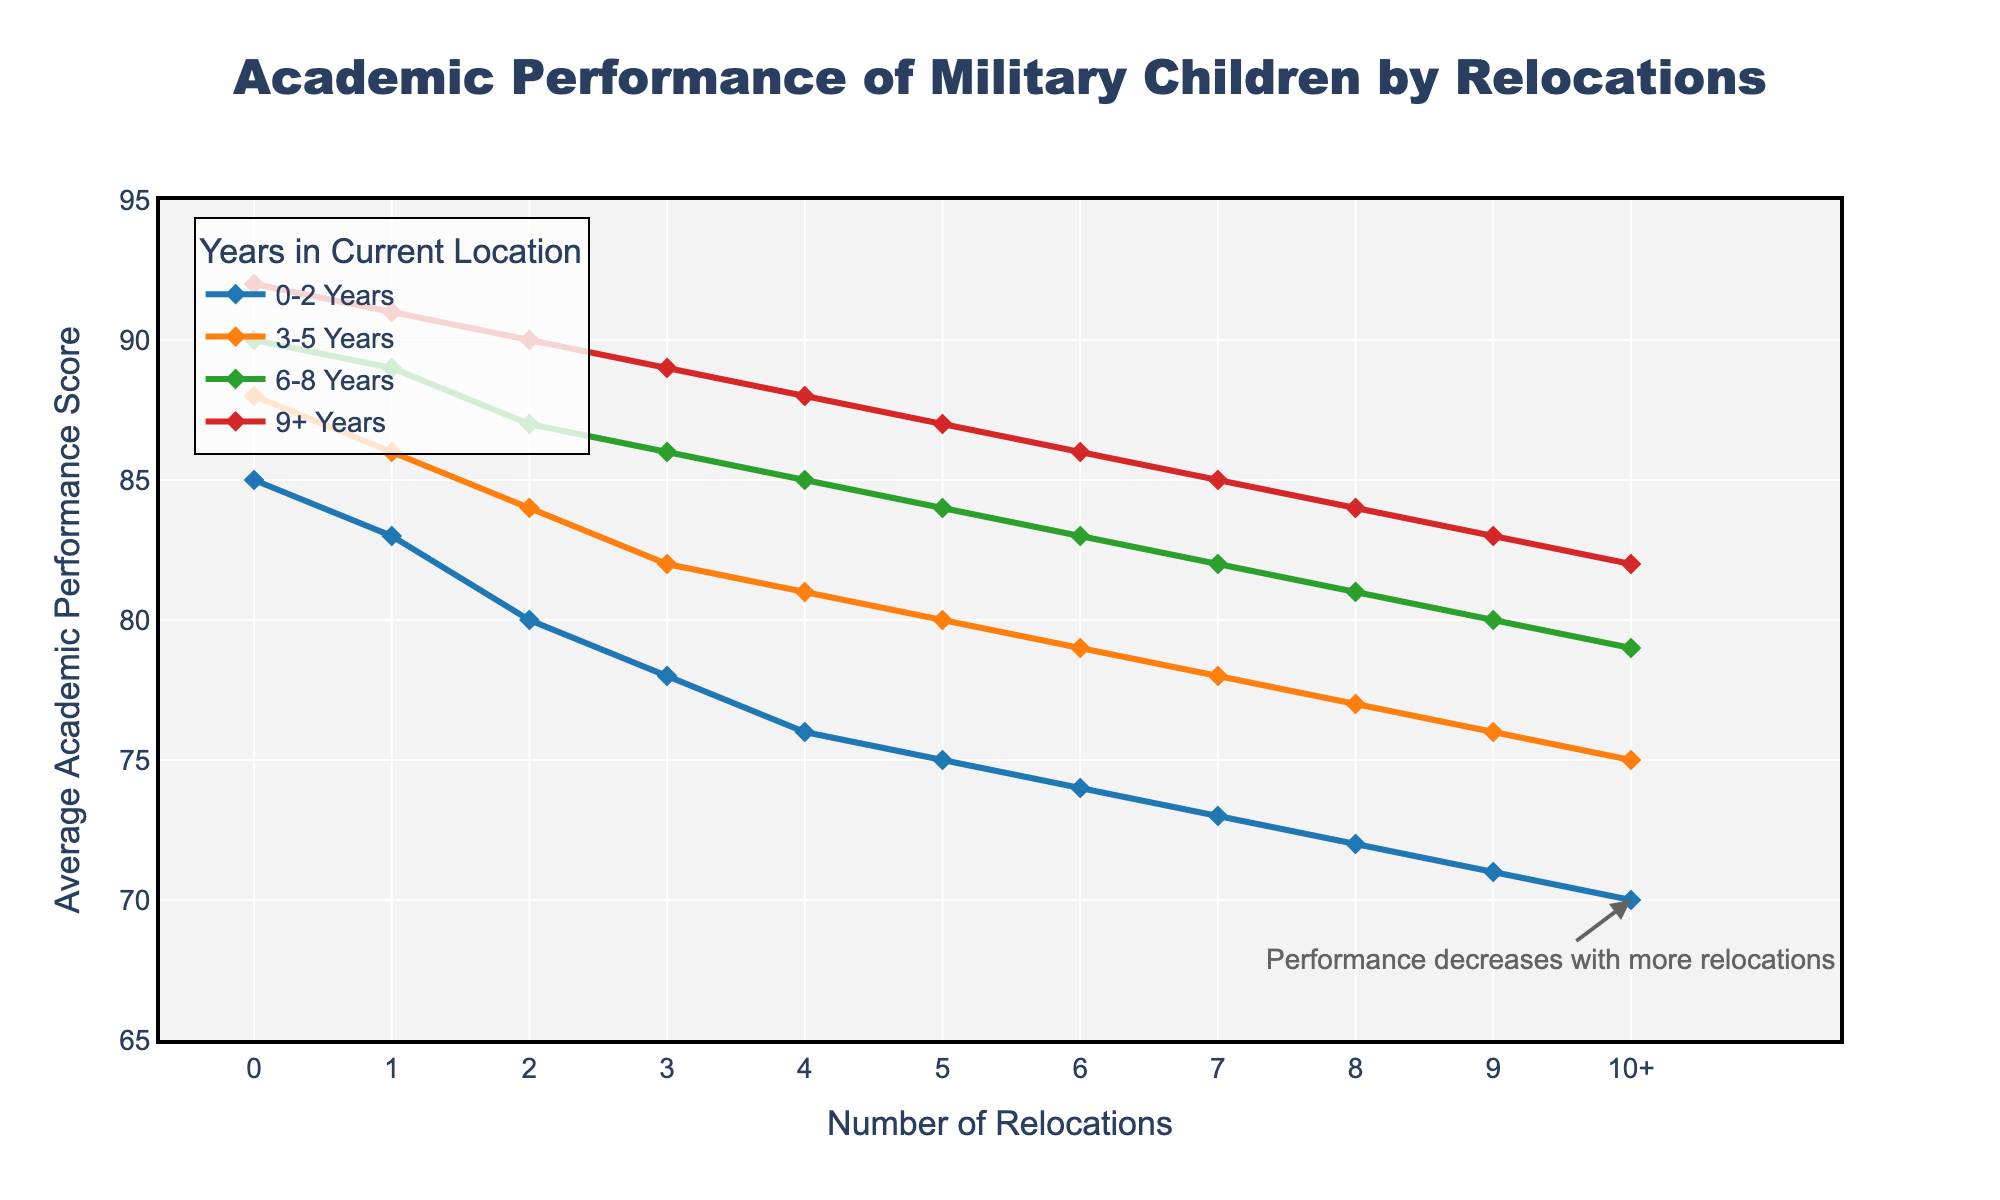What is the average performance score for children who have not been relocated? To calculate the average, sum the scores (85, 88, 90, 92) and divide by the number of scores: (85 + 88 + 90 + 92) / 4.
Answer: 88.75 Which group has the highest performance score for children in the 9+ years category? Compare the performance scores in the 9+ years category, the scores are 92, 91, 90, 89, etc. The highest score belongs to children with 0 relocations.
Answer: 0 relocations How does the academic performance change as the number of relocations increases? Observe that the performance scores decrease as the number of relocations increases, regardless of the years category.
Answer: Decreases At what number of relocations do children in the 6-8 years category first fall below an average performance score of 85? Assess the 6-8 years category scores: 90, 89, 87, 86, 85, 84, 83, 82, 81. The first score below 85 is 84 at 5 relocations.
Answer: 5 relocations For children with 3 relocations, which category shows the highest performance score? Compare the performance scores for 3 relocations: 78 (0-2 years), 82 (3-5 years), 86 (6-8 years), 89 (9+ years). The highest score is in the 9+ years category.
Answer: 9+ years Which year category has the steepest decline in academic performance as the number of relocations increases? Visually assess the slopes of the lines; the 0-2 years category shows a steeper decline compared to others.
Answer: 0-2 years What is the difference in performance scores between children with 2 relocations and those with 5 relocations in the 3-5 years category? Subtract the performance score for 5 relocations (80) from the score for 2 relocations (84) in the 3-5 years category: 84 - 80.
Answer: 4 Compare the performance scores of children with 7 relocations in the 0-2 years category to those in the 6-8 years category. Which category performs better? Look at the scores: 73 (0-2 years) vs. 82 (6-8 years). The 6-8 years category performs better.
Answer: 6-8 years category How much does the academic performance score decrease on average per relocation in the 9+ years category from 0 to 10+ relocations? Calculate the average difference per relocation: (92 - 82) / 10 = 1.
Answer: 1 Which color represents the 3-5 years category, and how can it be identified visually? Identify the color by referring to the legend; the 3-5 years category is represented by orange lines and markers.
Answer: Orange 